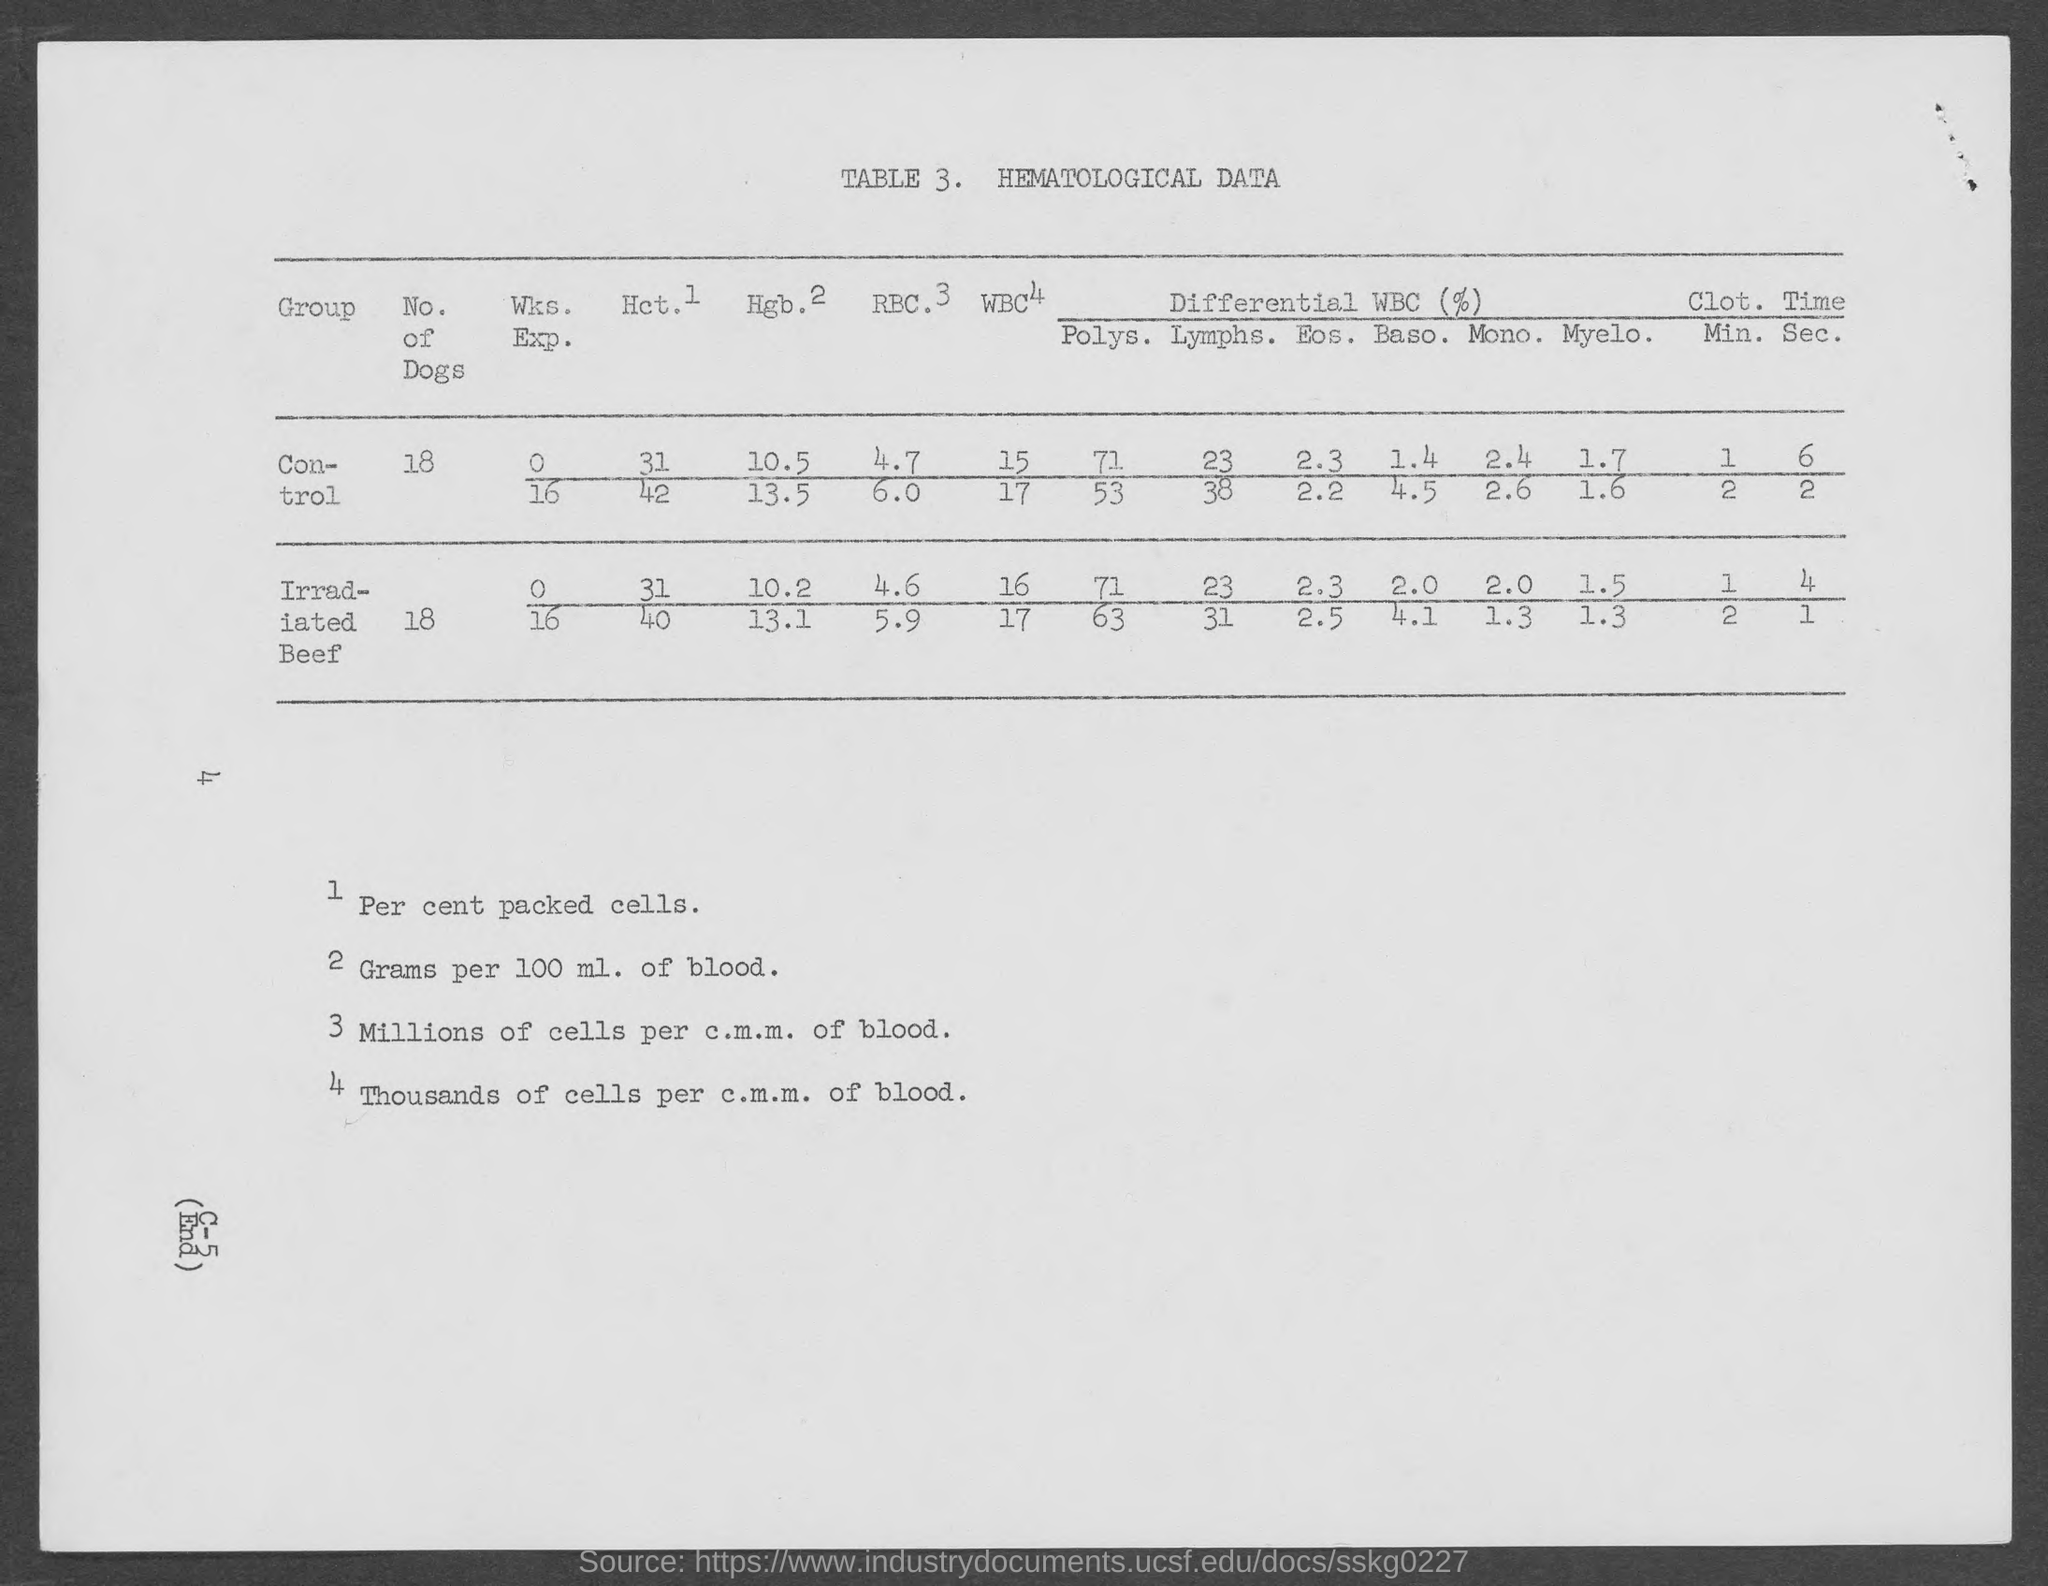Identify some key points in this picture. What is the number of dogs?" the man asked. "It is 18," the woman replied. 